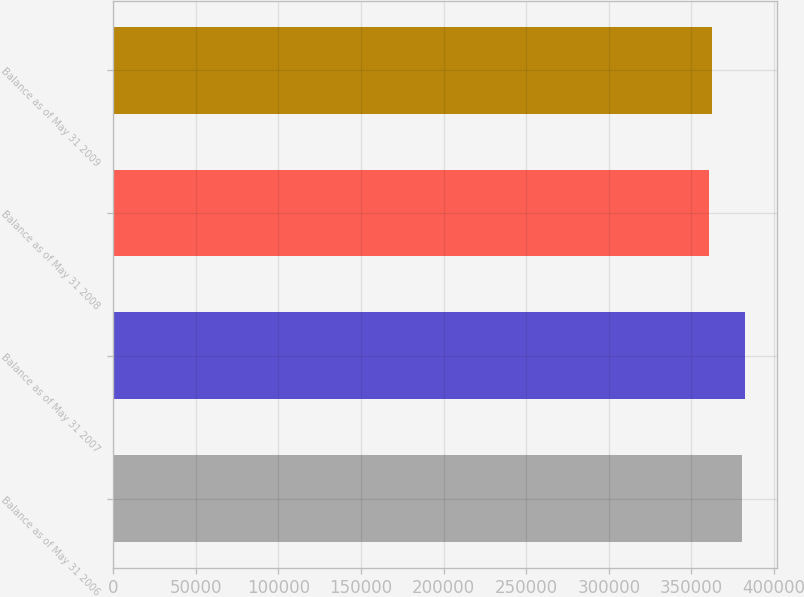Convert chart. <chart><loc_0><loc_0><loc_500><loc_500><bar_chart><fcel>Balance as of May 31 2006<fcel>Balance as of May 31 2007<fcel>Balance as of May 31 2008<fcel>Balance as of May 31 2009<nl><fcel>380303<fcel>382468<fcel>360500<fcel>362665<nl></chart> 